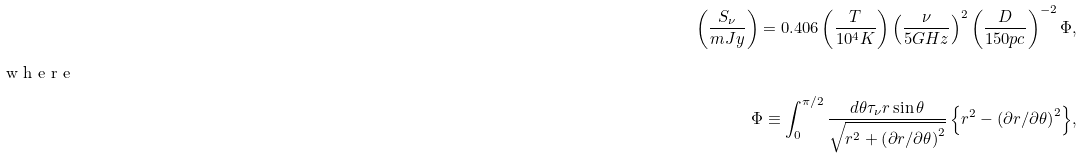<formula> <loc_0><loc_0><loc_500><loc_500>\left ( \frac { S _ { \nu } } { m J y } \right ) = 0 . 4 0 6 \left ( \frac { T } { 1 0 ^ { 4 } K } \right ) \left ( \frac { \nu } { 5 G H z } \right ) ^ { 2 } \left ( \frac { D } { 1 5 0 p c } \right ) ^ { - 2 } \Phi , \\ \intertext { w h e r e } \Phi \equiv \int ^ { \pi / 2 } _ { 0 } { \frac { d \theta \tau _ { \nu } r \sin \theta } { \sqrt { r ^ { 2 } + \left ( \partial r / \partial \theta \right ) ^ { 2 } } } \left \{ r ^ { 2 } - \left ( \partial r / \partial \theta \right ) ^ { 2 } \right \} } ,</formula> 